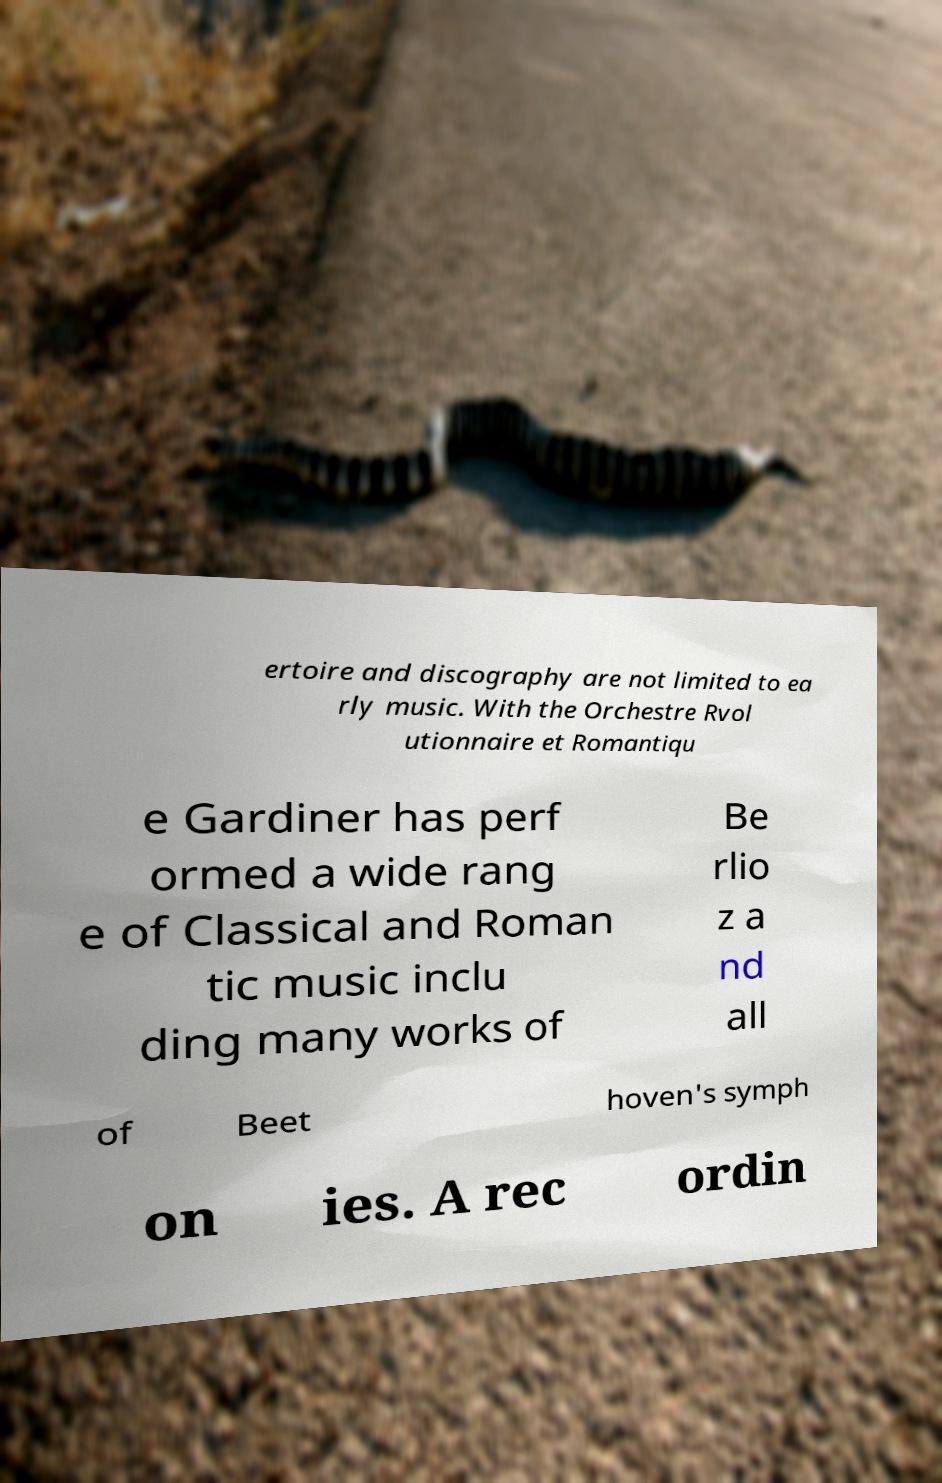Can you accurately transcribe the text from the provided image for me? ertoire and discography are not limited to ea rly music. With the Orchestre Rvol utionnaire et Romantiqu e Gardiner has perf ormed a wide rang e of Classical and Roman tic music inclu ding many works of Be rlio z a nd all of Beet hoven's symph on ies. A rec ordin 